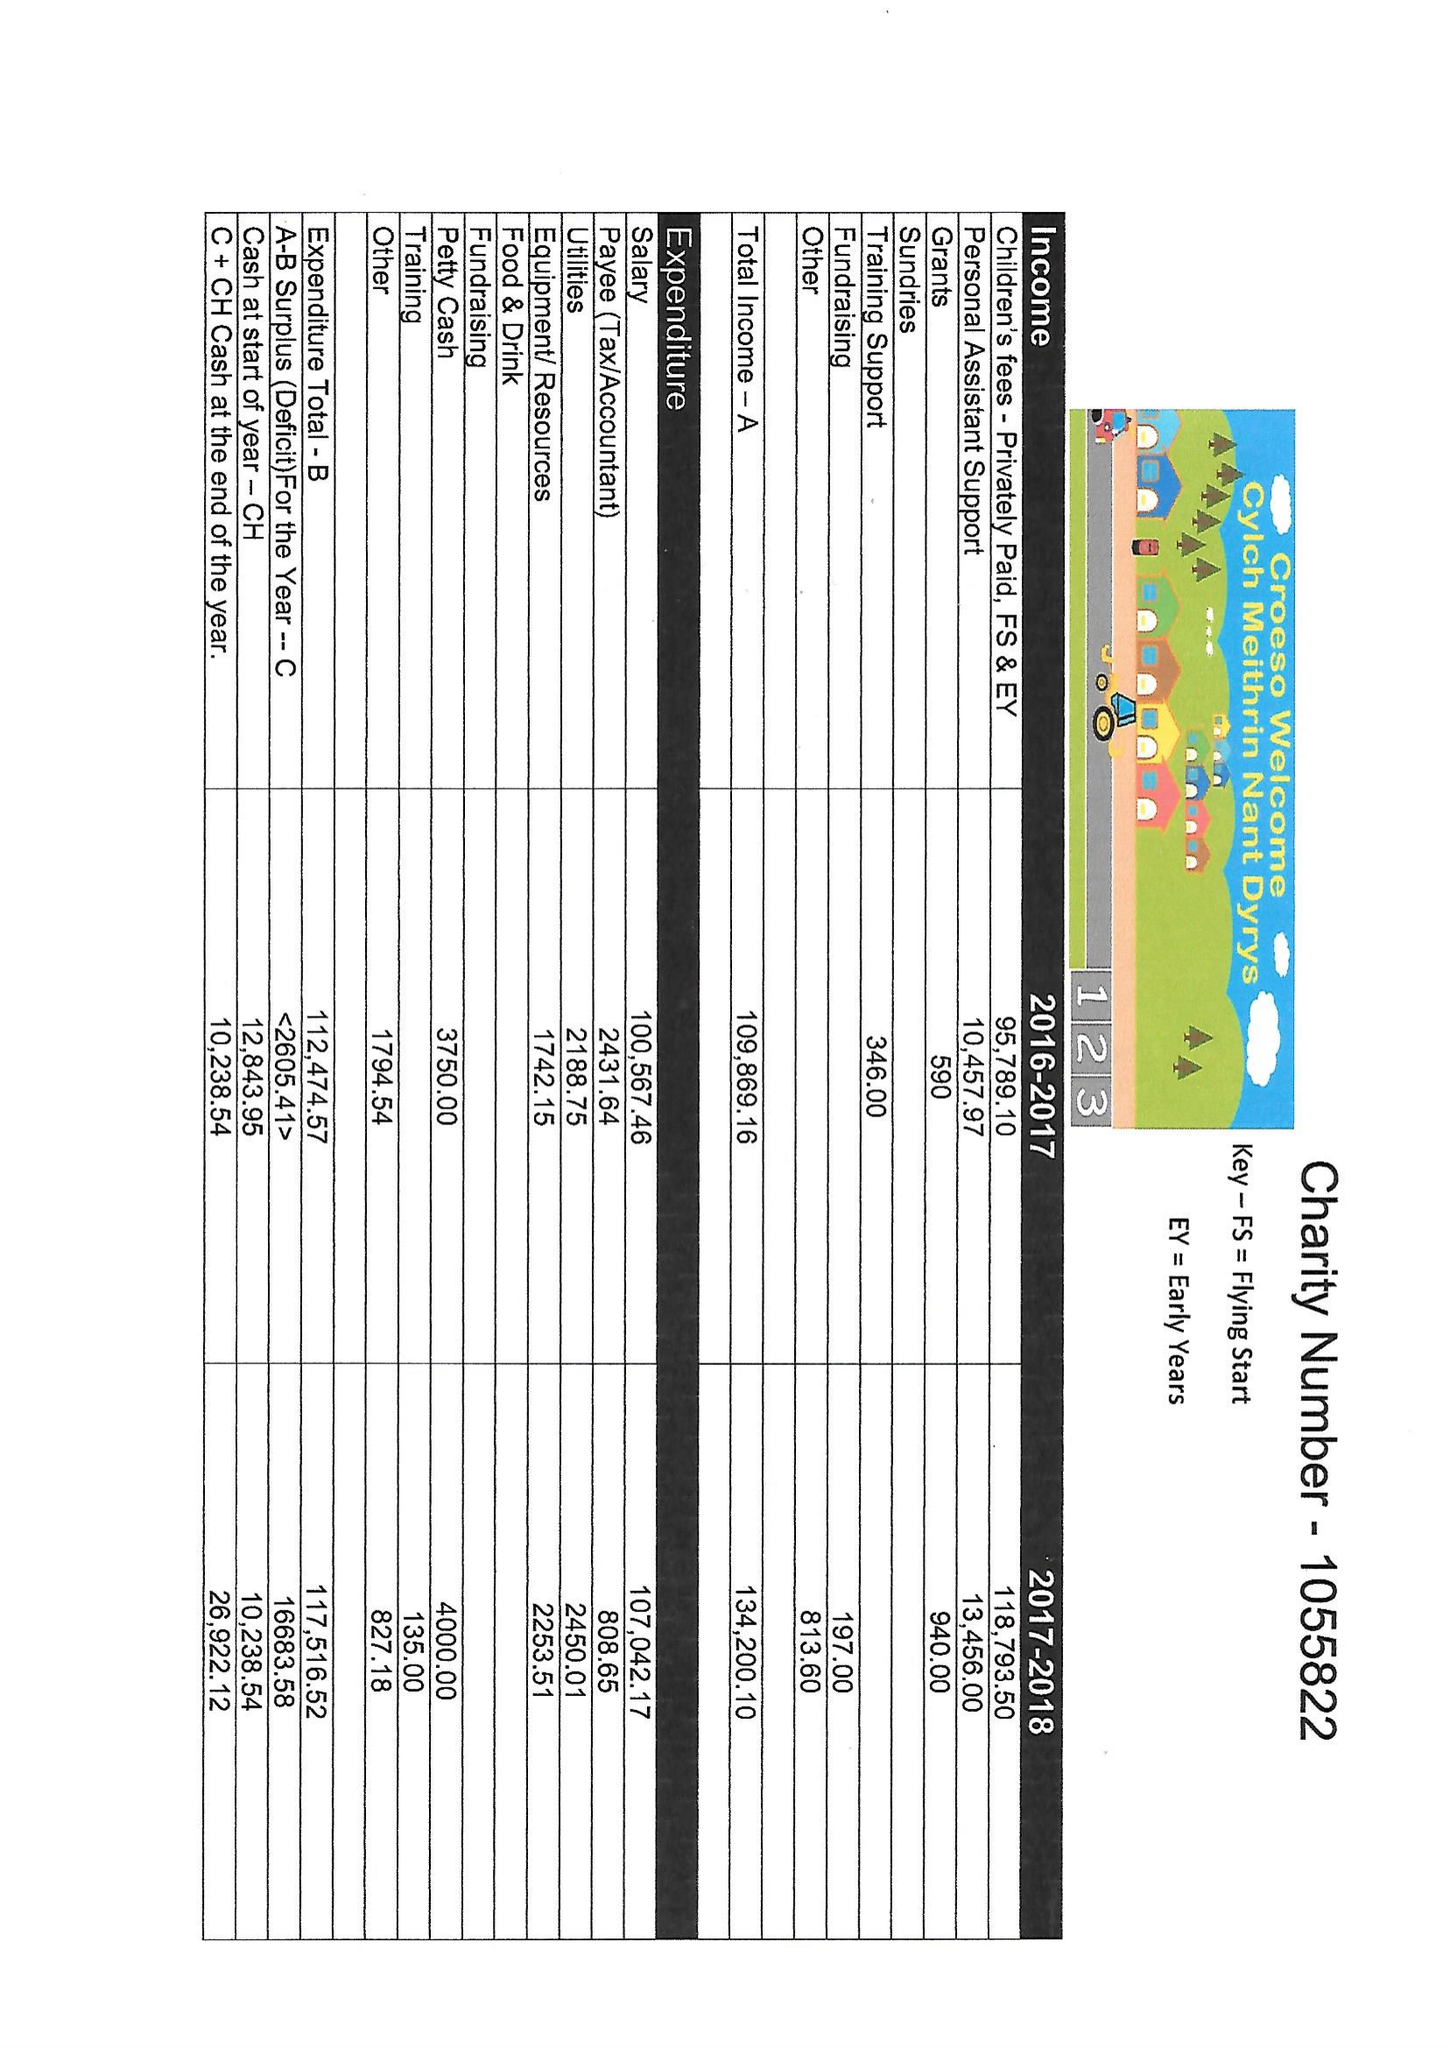What is the value for the income_annually_in_british_pounds?
Answer the question using a single word or phrase. 134200.00 